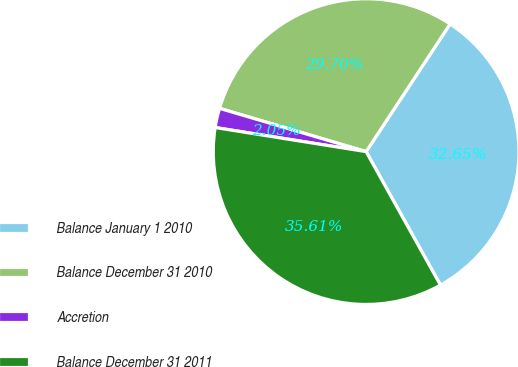Convert chart. <chart><loc_0><loc_0><loc_500><loc_500><pie_chart><fcel>Balance January 1 2010<fcel>Balance December 31 2010<fcel>Accretion<fcel>Balance December 31 2011<nl><fcel>32.65%<fcel>29.7%<fcel>2.05%<fcel>35.61%<nl></chart> 